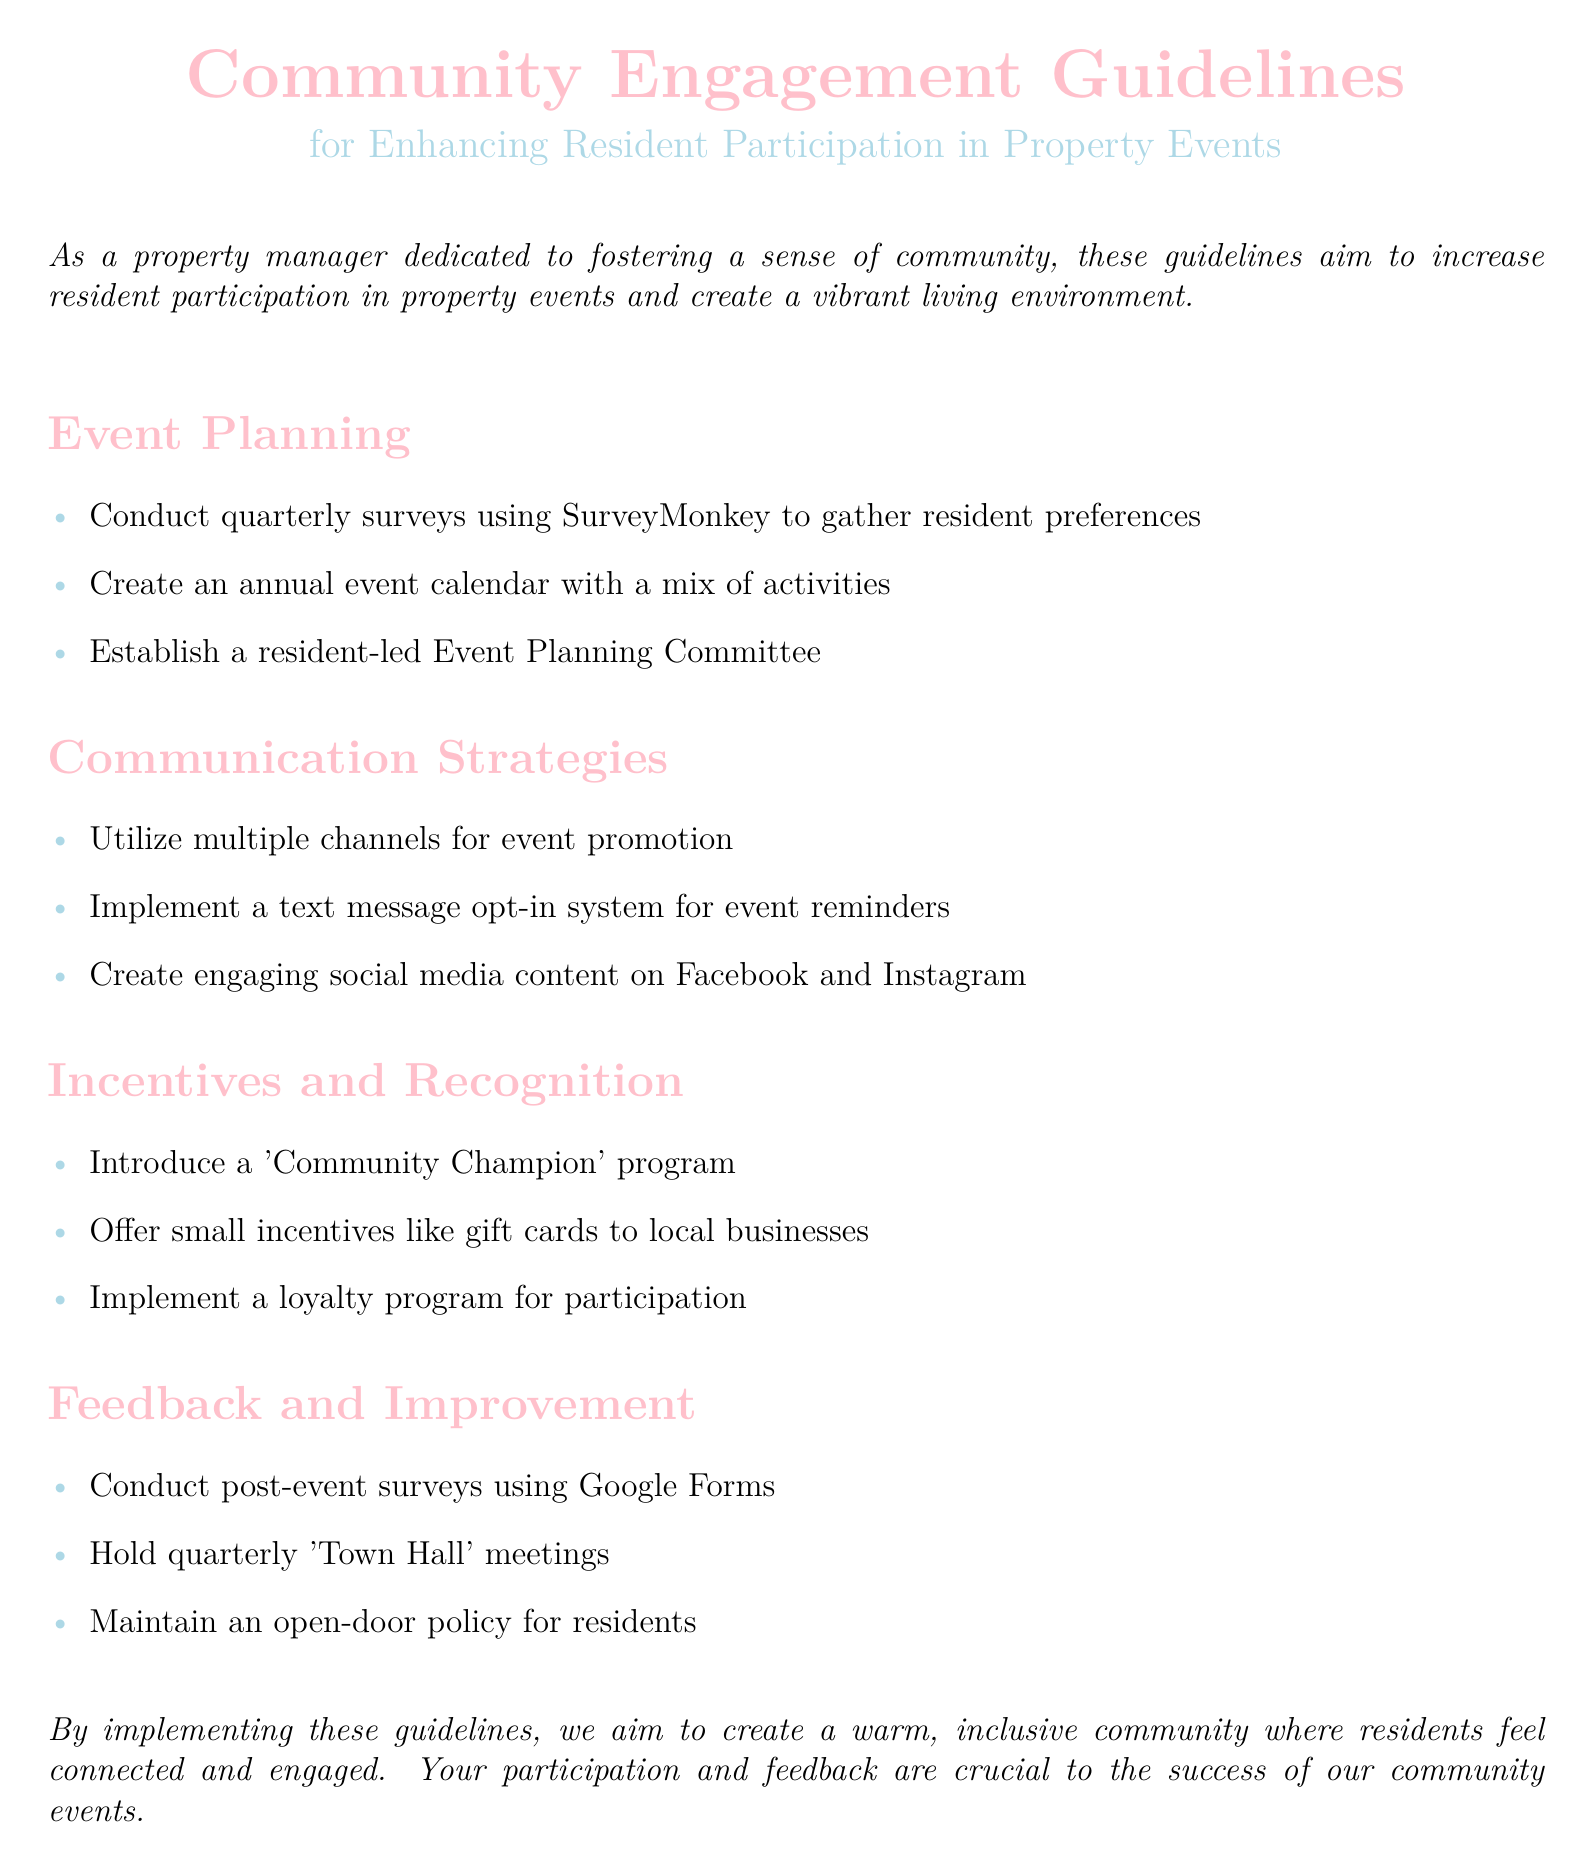What is the main focus of the Community Engagement Guidelines? The guidelines aim to increase resident participation in property events and create a vibrant living environment.
Answer: Increase resident participation How often should surveys be conducted to gather resident preferences? The document specifies that surveys should be conducted quarterly.
Answer: Quarterly What program is introduced to recognize active residents? The guidelines mention a 'Community Champion' program for recognition.
Answer: Community Champion Which platform is suggested for event promotion? The guidelines recommend using multiple channels, including social media like Facebook and Instagram.
Answer: Facebook and Instagram What is the suggested method for gathering post-event feedback? The document advises conducting post-event surveys using Google Forms.
Answer: Google Forms How many activities should the annual event calendar include? The guidelines suggest creating an annual event calendar with a mix of activities, implying multiple activities but not specifying a number.
Answer: A mix of activities What type of meetings are held quarterly for resident input? The document states that quarterly 'Town Hall' meetings should be held for feedback.
Answer: Town Hall meetings What is one of the small incentives offered for participation? The guidelines mention offering gift cards to local businesses as a small incentive.
Answer: Gift cards What type of policy is maintained for residents in the property? The document states that an open-door policy should be maintained for residents to provide feedback.
Answer: Open-door policy 